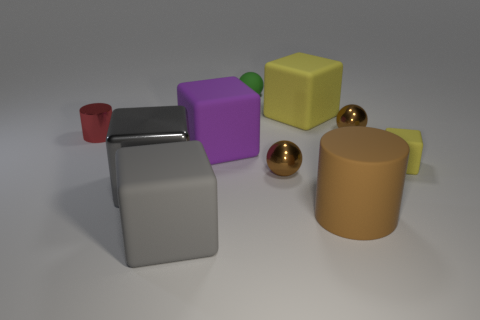Is the color of the big shiny block the same as the big block in front of the big shiny thing? Yes, the color of the big shiny block, which appears to have a reflective surface, is the same as the large matte-finished block positioned in front of it, both exhibiting a similar hue of grey. 